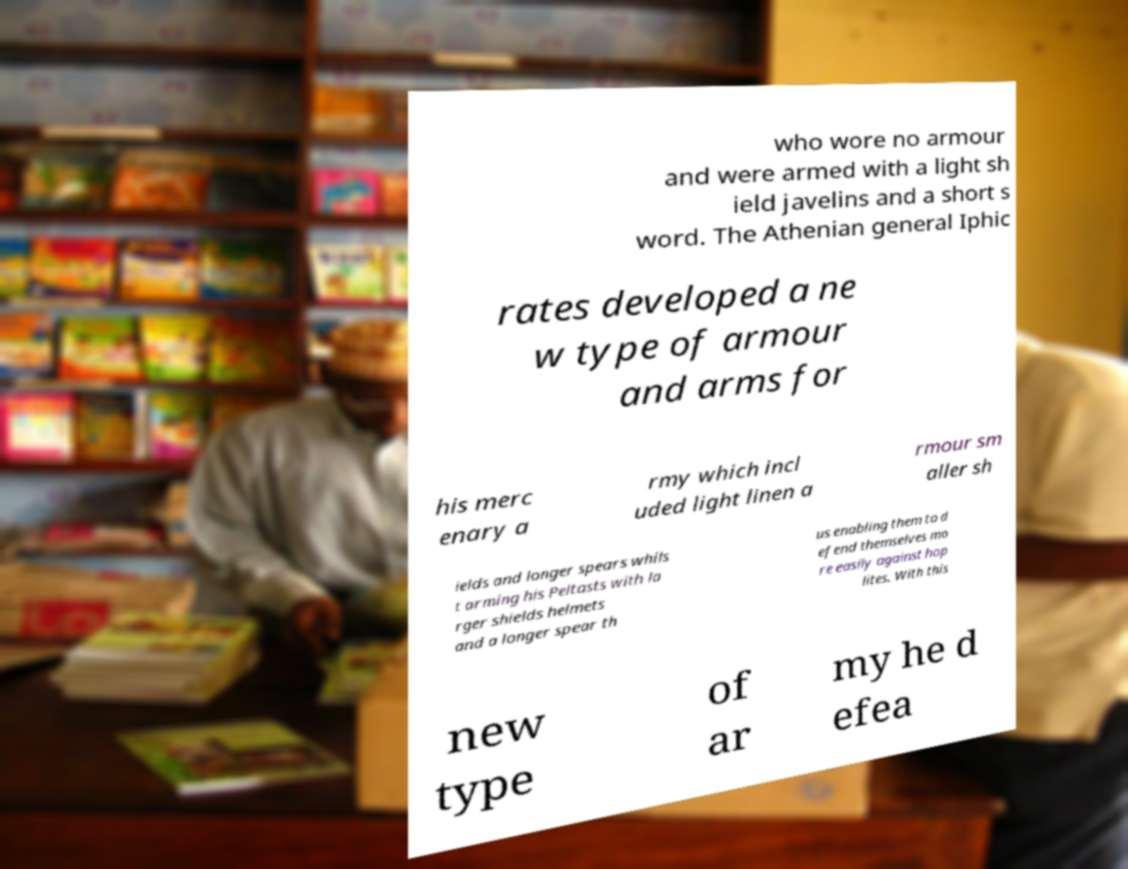What messages or text are displayed in this image? I need them in a readable, typed format. who wore no armour and were armed with a light sh ield javelins and a short s word. The Athenian general Iphic rates developed a ne w type of armour and arms for his merc enary a rmy which incl uded light linen a rmour sm aller sh ields and longer spears whils t arming his Peltasts with la rger shields helmets and a longer spear th us enabling them to d efend themselves mo re easily against hop lites. With this new type of ar my he d efea 